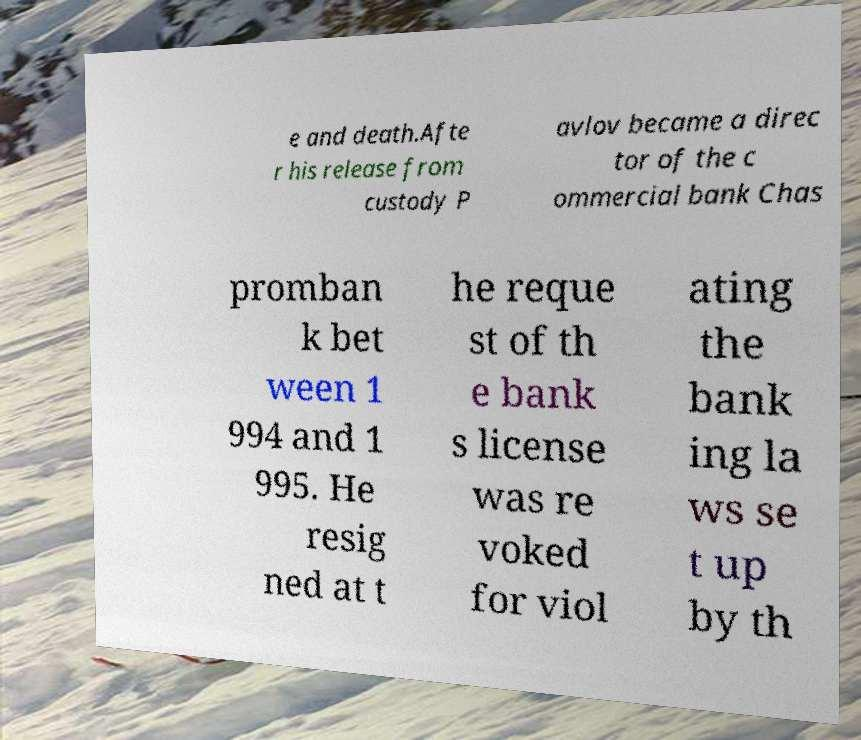I need the written content from this picture converted into text. Can you do that? e and death.Afte r his release from custody P avlov became a direc tor of the c ommercial bank Chas promban k bet ween 1 994 and 1 995. He resig ned at t he reque st of th e bank s license was re voked for viol ating the bank ing la ws se t up by th 